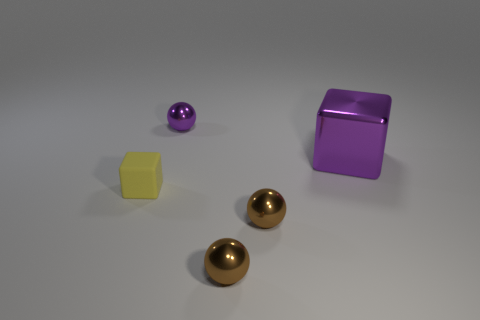Is there a red matte block that has the same size as the matte object?
Provide a succinct answer. No. Do the cube that is behind the yellow rubber object and the small purple sphere have the same size?
Offer a very short reply. No. There is a object that is behind the matte thing and on the left side of the purple metal cube; what shape is it?
Offer a very short reply. Sphere. Are there more purple balls that are in front of the yellow object than metallic objects?
Offer a very short reply. No. There is a cube that is the same material as the purple ball; what is its size?
Your response must be concise. Large. How many tiny balls have the same color as the big cube?
Your answer should be very brief. 1. Is the color of the thing to the left of the purple shiny ball the same as the metallic cube?
Your answer should be very brief. No. Are there the same number of large purple metallic things behind the tiny purple object and objects to the left of the large metal object?
Provide a short and direct response. No. Are there any other things that are the same material as the small cube?
Your answer should be compact. No. The block right of the tiny purple sphere is what color?
Offer a very short reply. Purple. 